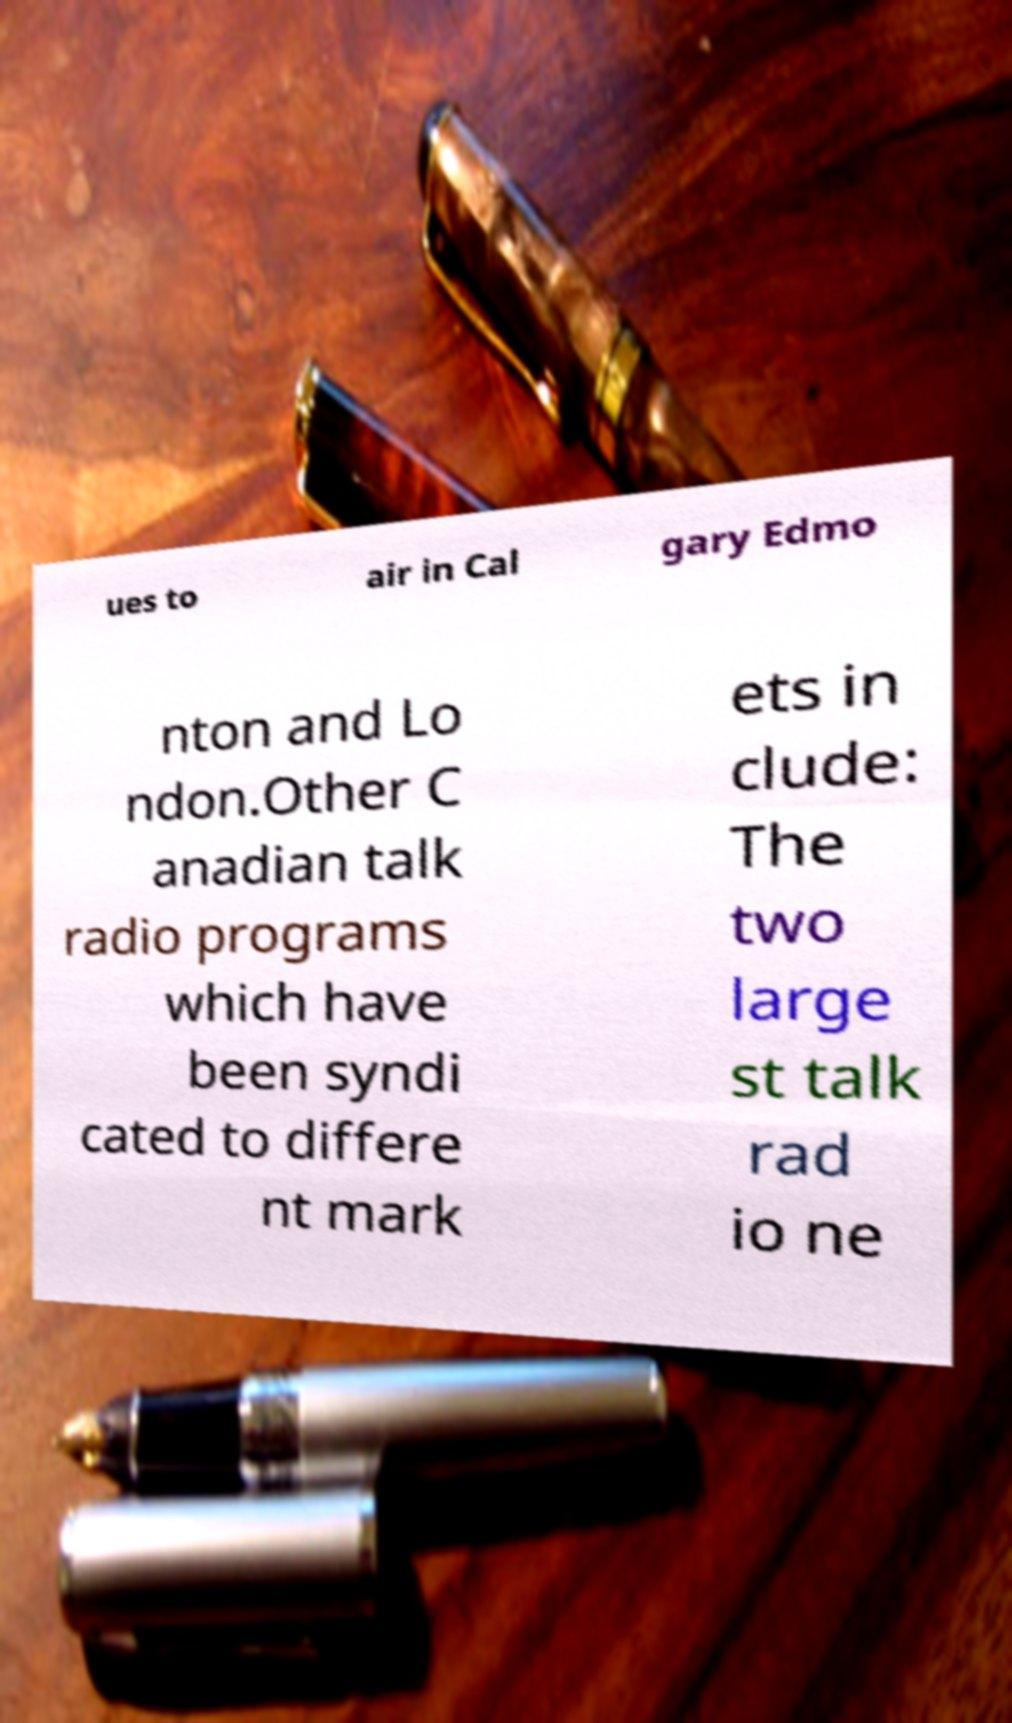There's text embedded in this image that I need extracted. Can you transcribe it verbatim? ues to air in Cal gary Edmo nton and Lo ndon.Other C anadian talk radio programs which have been syndi cated to differe nt mark ets in clude: The two large st talk rad io ne 